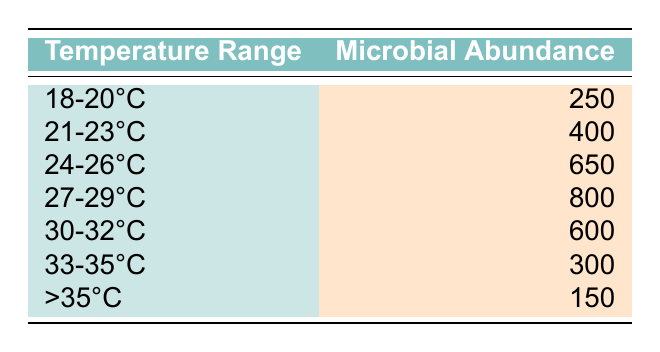What is the microbial abundance in the temperature range 24-26°C? The table shows that the microbial abundance for the range 24-26°C is 650.
Answer: 650 Which temperature range has the highest microbial abundance? By looking at the table, the highest microbial abundance is in the 27-29°C range, which has a value of 800.
Answer: 27-29°C What is the total microbial abundance across all temperature ranges? To find the total, sum all the microbial abundance values: 250 + 400 + 650 + 800 + 600 + 300 + 150 = 3150.
Answer: 3150 Is the microbial abundance greater in the range of 21-23°C than in 33-35°C? The abundance for 21-23°C is 400, while for 33-35°C it is 300. Since 400 is greater than 300, the statement is true.
Answer: Yes What is the average microbial abundance across the temperature ranges? To calculate the average, sum all the abundances (3150) and divide by the number of temperature ranges (7): 3150/7 = 450.
Answer: 450 How does the microbial abundance change as the temperature increases from the range of 18-20°C to 30-32°C? By comparing these ranges, 18-20°C has 250, and 30-32°C has 600. The abundance increases from 250 to 600, showing a positive trend.
Answer: Increased What is the difference in microbial abundance between the ranges 27-29°C and >35°C? The microbial abundance in the 27-29°C range is 800, and in the >35°C, it is 150. The difference is 800 - 150 = 650.
Answer: 650 Which three temperature ranges have microbial abundances above 500? The ranges above 500 are 24-26°C (650), 27-29°C (800), and 30-32°C (600). Therefore, there are three such ranges: 24-26°C, 27-29°C, and 30-32°C.
Answer: 24-26°C, 27-29°C, 30-32°C Is there any temperature range where microbial abundance is below 200? The table shows that the lowest recorded abundance is 150 in the >35°C category, which is below 200. Therefore, the answer is yes.
Answer: Yes 